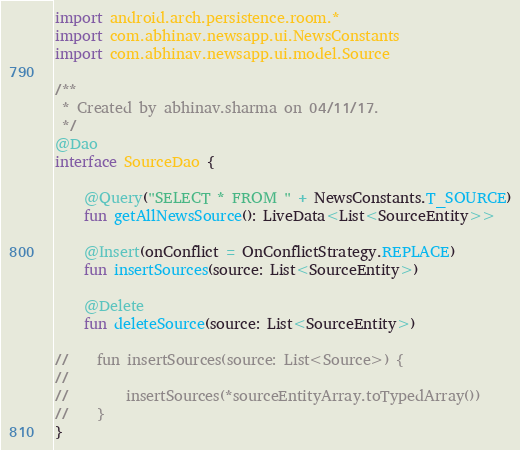Convert code to text. <code><loc_0><loc_0><loc_500><loc_500><_Kotlin_>import android.arch.persistence.room.*
import com.abhinav.newsapp.ui.NewsConstants
import com.abhinav.newsapp.ui.model.Source

/**
 * Created by abhinav.sharma on 04/11/17.
 */
@Dao
interface SourceDao {

    @Query("SELECT * FROM " + NewsConstants.T_SOURCE)
    fun getAllNewsSource(): LiveData<List<SourceEntity>>

    @Insert(onConflict = OnConflictStrategy.REPLACE)
    fun insertSources(source: List<SourceEntity>)

    @Delete
    fun deleteSource(source: List<SourceEntity>)

//    fun insertSources(source: List<Source>) {
//
//        insertSources(*sourceEntityArray.toTypedArray())
//    }
}</code> 